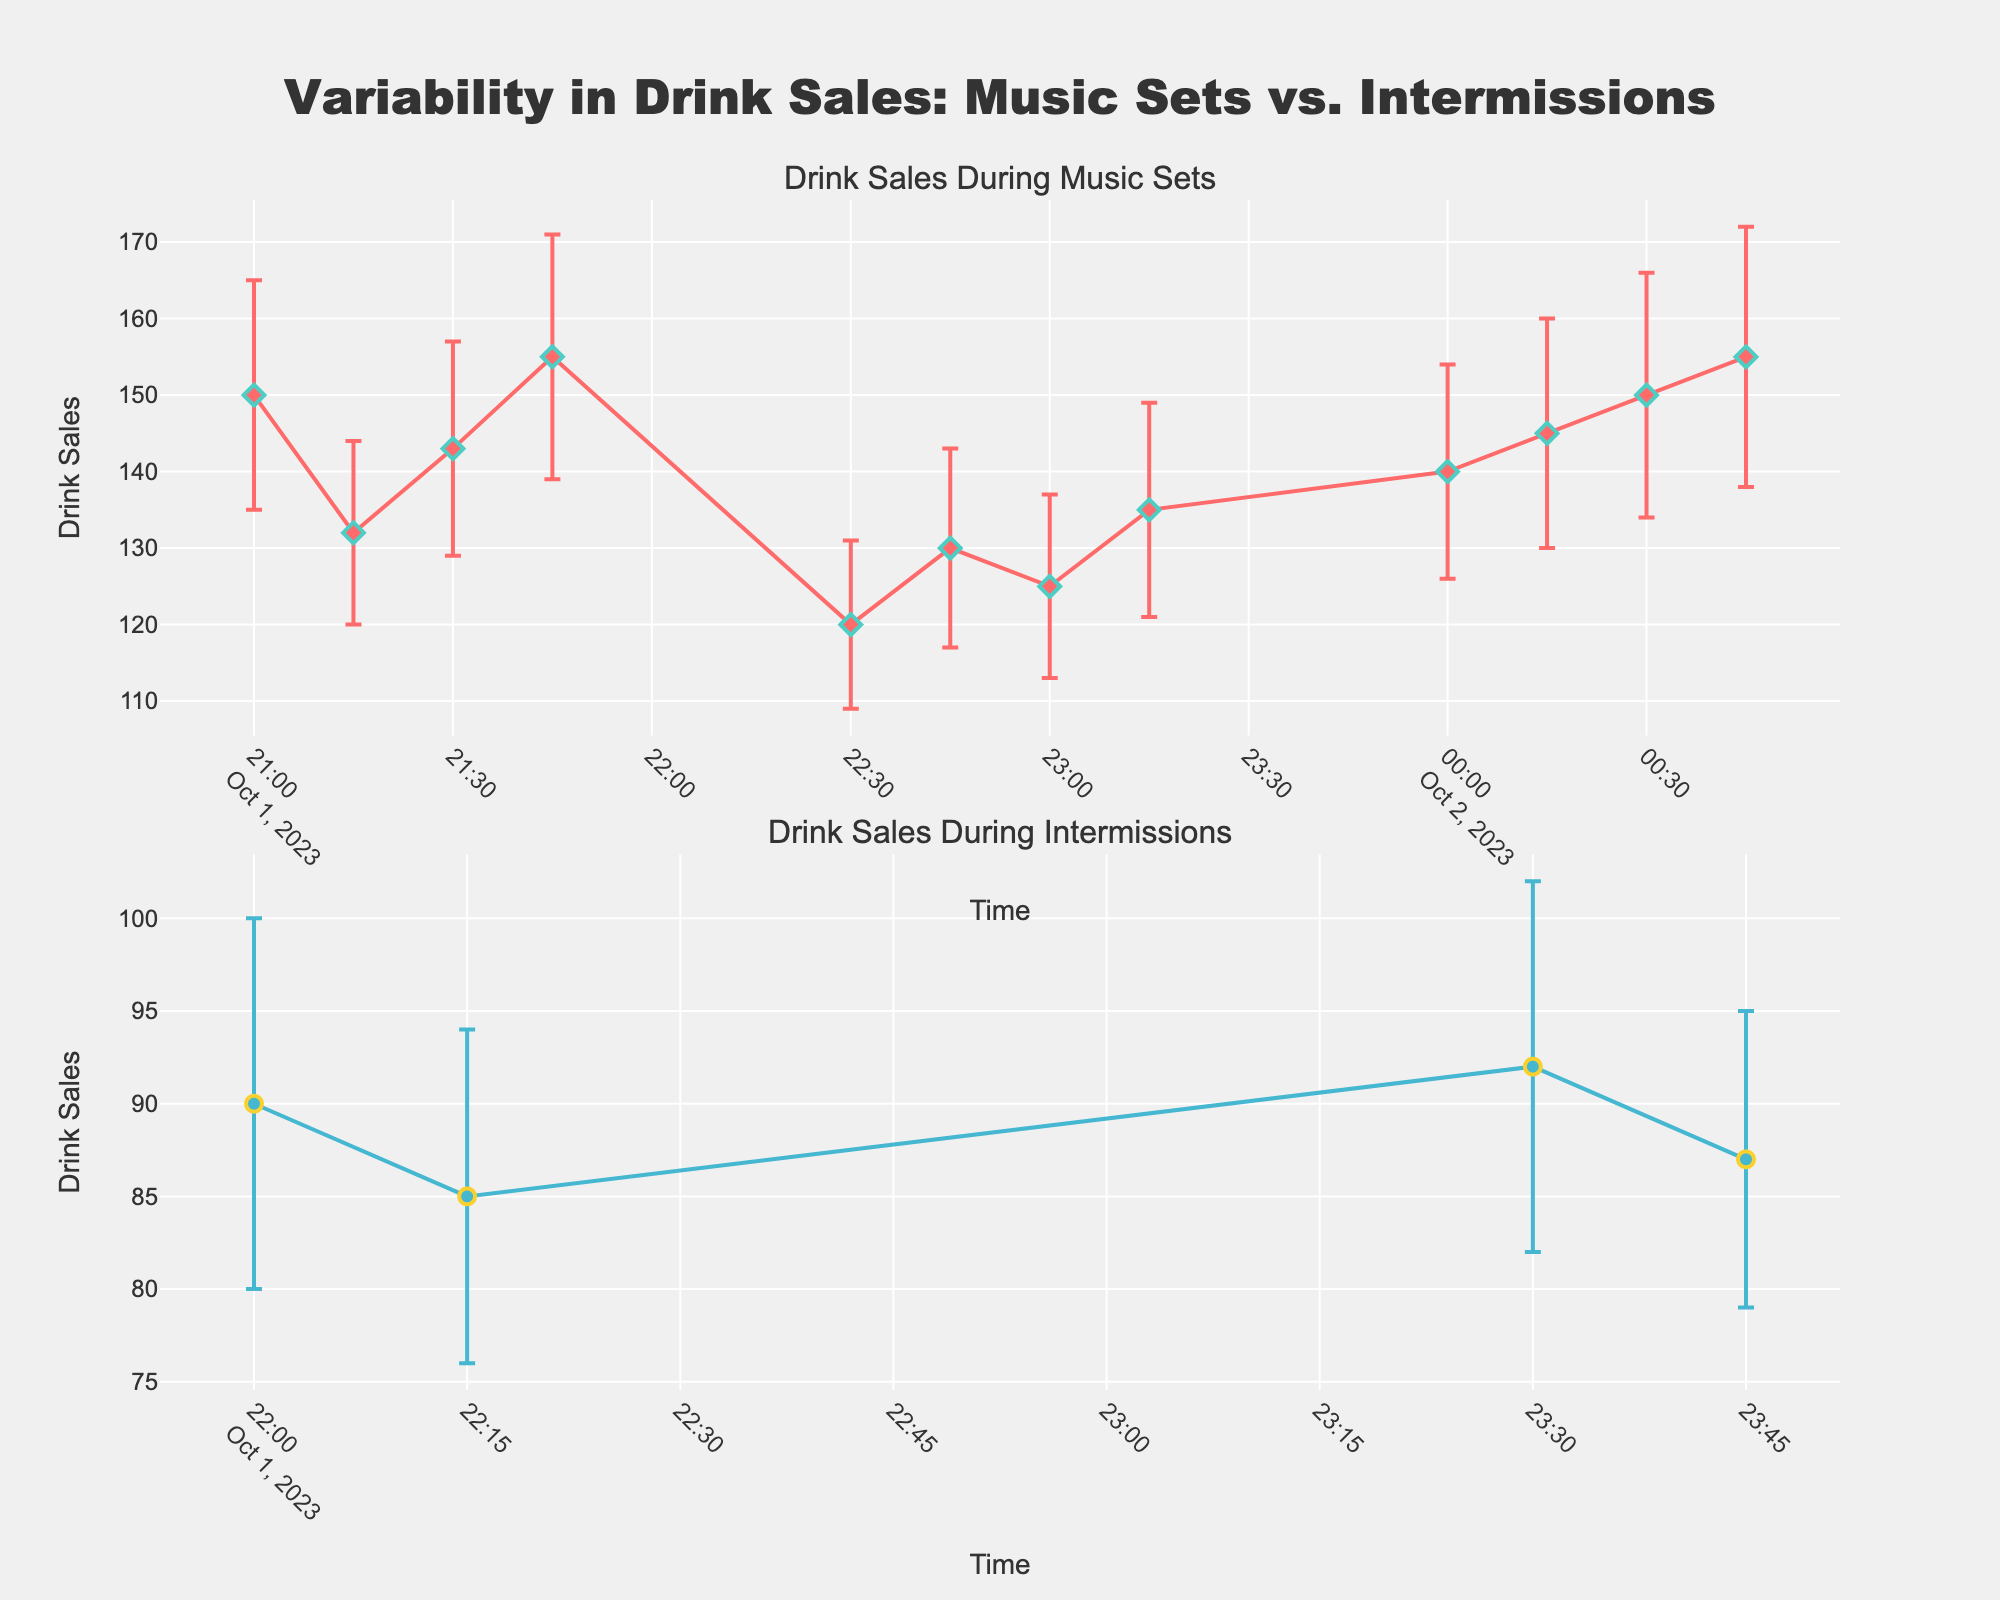What are the two periods compared in the figure? The figure compares two periods: "Music Sets" and "Intermissions." This can be seen in the subplot titles.
Answer: Music Sets and Intermissions Which period title is placed in the top subplot? The top subplot has the title "Drink Sales During Music Sets."
Answer: Drink Sales During Music Sets What is the range of drink sales during music sets? The drink sales during music sets ranges from the lowest value of 120 at 22:30 to the highest value of 155 at 21:45 and 00:45.
Answer: 120 to 155 How does the variability in drink sales during intermissions compare to music sets? Looking at the error bars, drink sales variability during intermissions appear smaller than during music sets. Intermission sales have lower standard deviations (8-11) while music set sales have higher standard deviations (12-17).
Answer: Smaller variability during intermissions What color represents the drink sales during intermissions in the plot? The drink sales during intermissions are represented by a blue line and circle markers.
Answer: Blue At what time does the lowest drink sale occur during the music sets, and what is the value? The lowest drink sale during the music sets occurs at 22:30 with a value of 120 drinks.
Answer: 22:30, 120 drinks Compare the drink sales at 21:00 and 22:45. Which is higher and by how much? Drink sales at 21:00 are 150, while at 22:45 they are 130. The sales at 21:00 are higher by 20 drinks.
Answer: 21:00 by 20 drinks What is the average drink sales during intermissions only? The drink sales during intermissions are 90, 85, 92, and 87. The average is calculated as (90 + 85 + 92 + 87) / 4 = 88.5.
Answer: 88.5 Which period, music sets or intermissions, has more data points? Music sets have more data points. There are 10 points compared to 6 points for intermissions.
Answer: Music sets If the sales during the intermission at 23:30 were exactly on the predicted line of ± one standard deviation from the mean, what would its drink sales be? The mean drink sales during intermissions is 88.5, with standard deviations ranging from 8 to 11. As 92 is within one standard deviation above the mean, it falls on the predicted line.
Answer: 92 